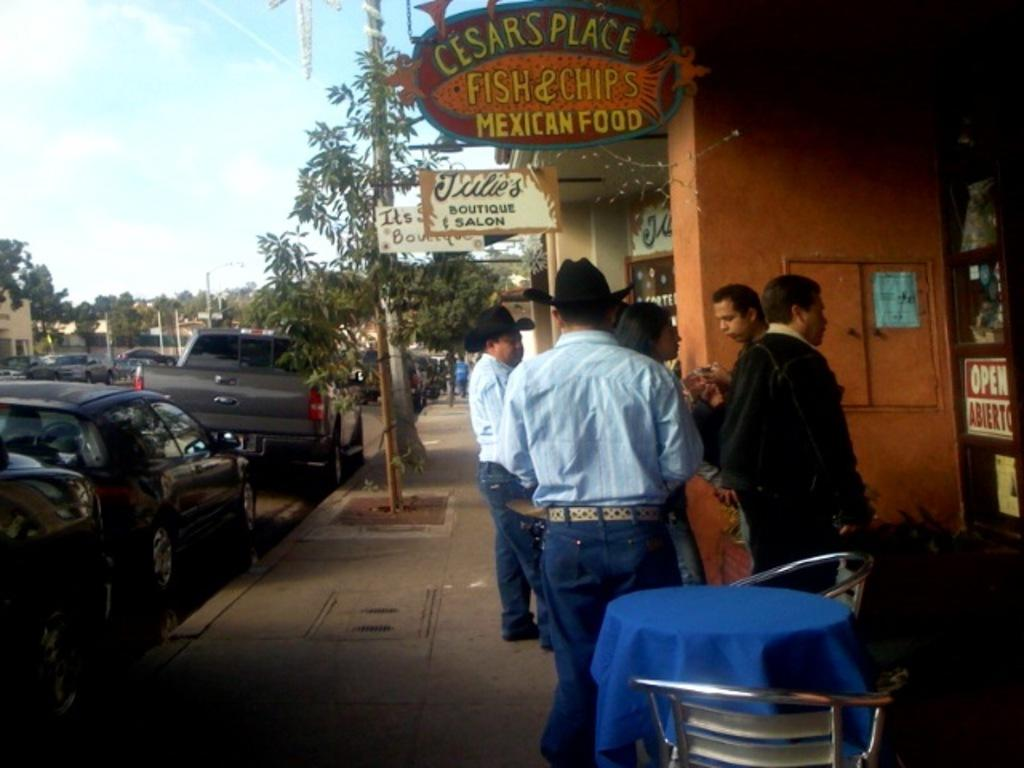How many people are in the group visible in the image? There is a group of persons in the image, but the exact number cannot be determined from the provided facts. Where is the group of persons located in the image? The group of persons is standing near a building in the image. What furniture is present in the image? There is a table and a chair in the image. What type of signage is visible in the image? There is a hoarding in the image. What type of vegetation is present in the image? There is a tree in the image. What type of vehicle is visible in the image? There is a car in the image. What is visible in the sky in the image? The sky is visible in the image, but no specific details about its appearance are provided. How many cherries are hanging from the tree in the image? There is no mention of cherries in the provided facts, and therefore no such detail can be observed in the image. What time is displayed on the clock in the image? There is no clock present in the image, so it is not possible to answer this question. 